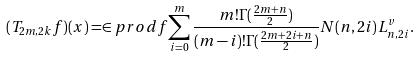Convert formula to latex. <formula><loc_0><loc_0><loc_500><loc_500>( T _ { 2 m , 2 k } f ) ( x ) = \in p r o d { f } { \sum _ { i = 0 } ^ { m } \frac { m ! \Gamma ( \frac { 2 m + n } { 2 } ) } { ( m - i ) ! \Gamma ( \frac { 2 m + 2 i + n } { 2 } ) } N ( n , 2 i ) L ^ { v } _ { n , 2 i } } .</formula> 